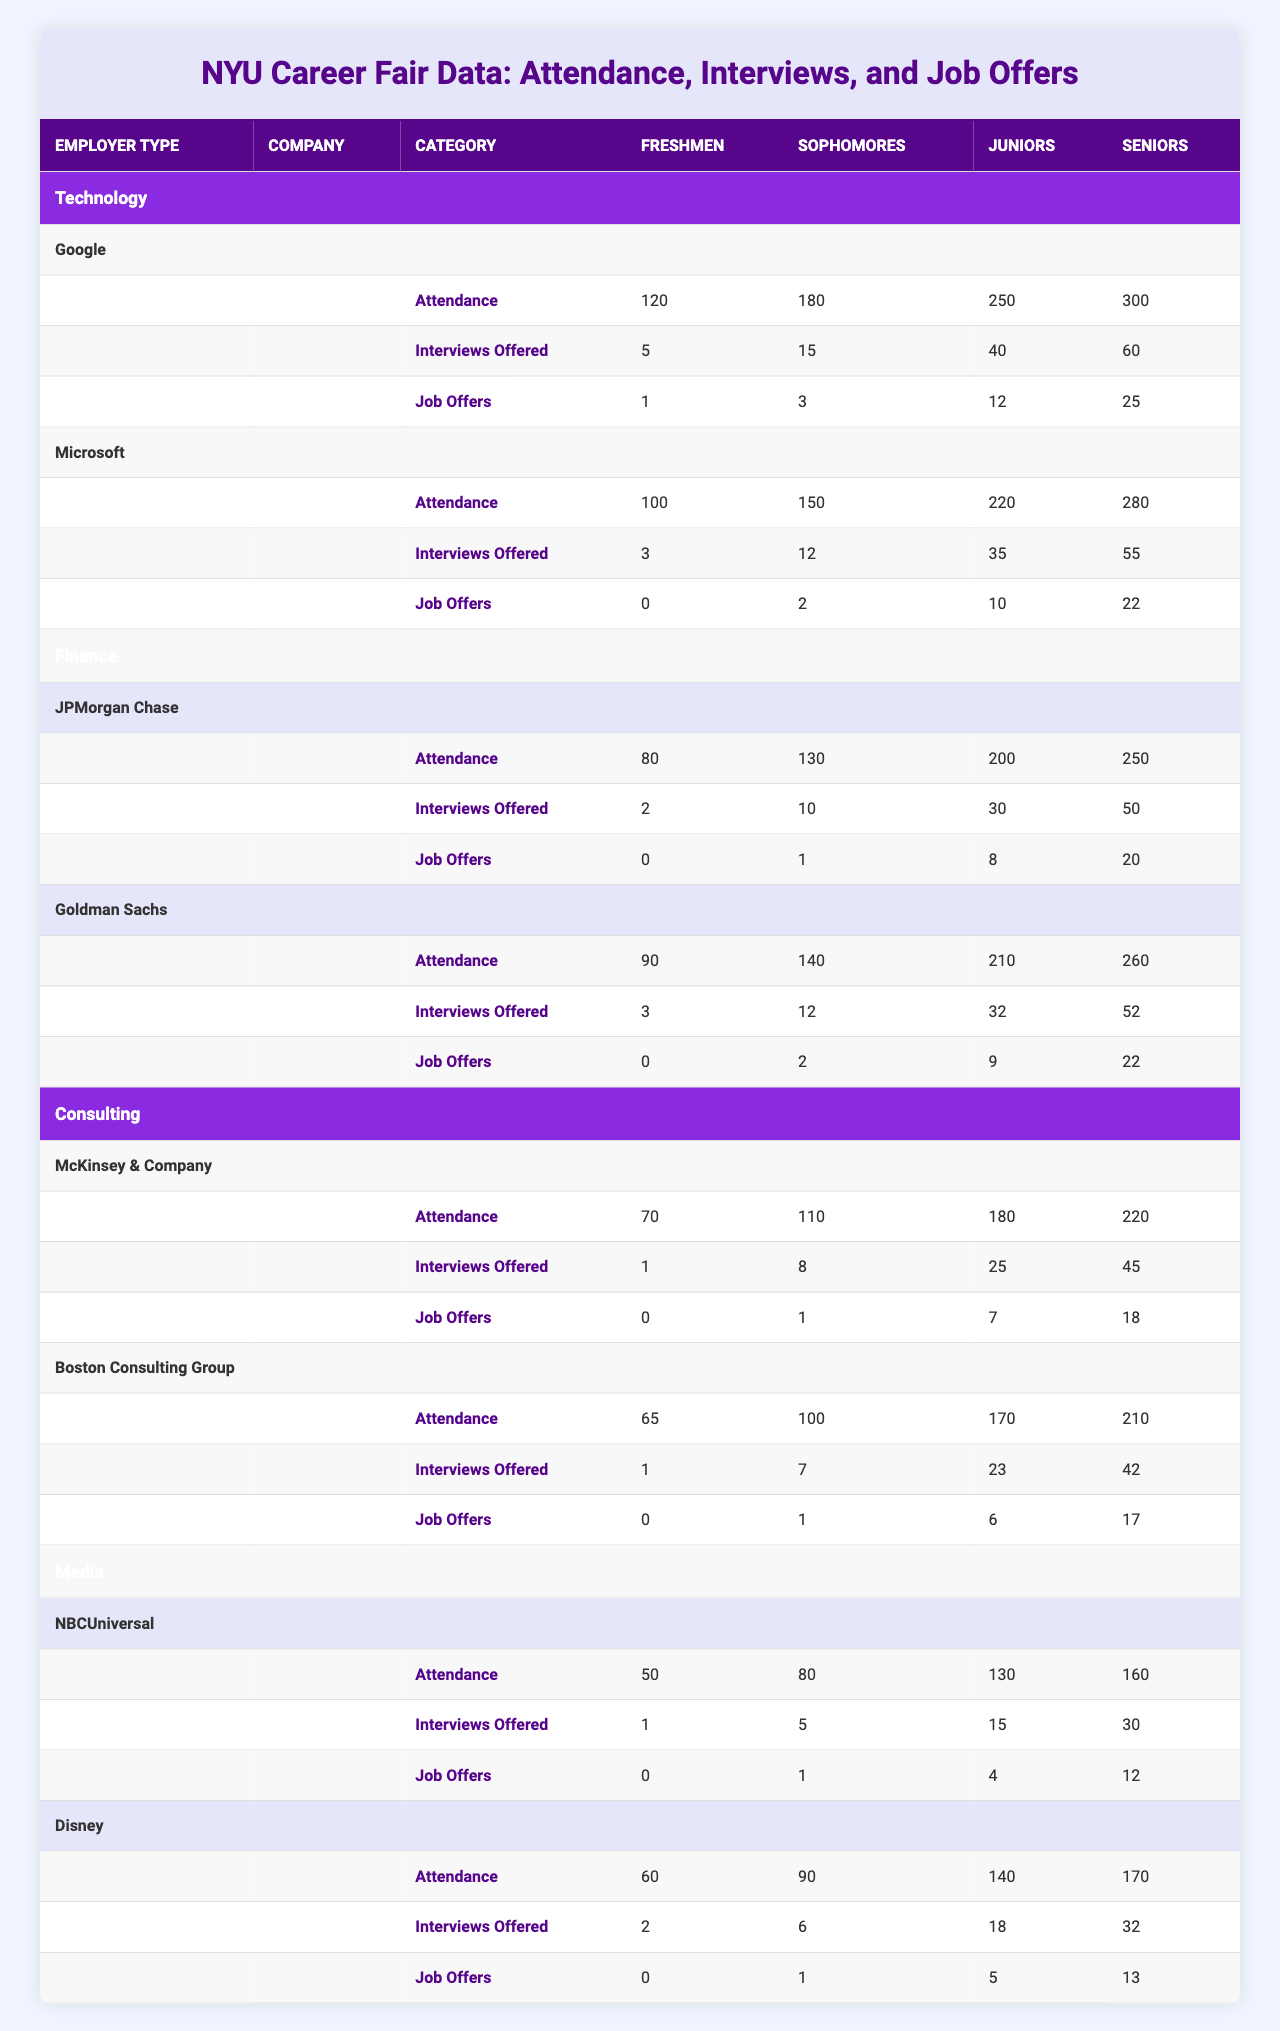What is the total attendance for Google among all student years? Google's attendance for Freshmen is 120, Sophomores is 180, Juniors is 250, and Seniors is 300. Adding these values together: 120 + 180 + 250 + 300 = 850.
Answer: 850 Which company had the highest number of job offers for Seniors? Looking at the data, Google offered 25 job offers to Seniors, while other companies like JPMorgan Chase offered 20 and Goldman Sachs also offered 22. Therefore, Google has the highest number of job offers for Seniors.
Answer: Google What is the average number of job offers for Sophomores across all companies? For Sophomores: Google offered 3, Microsoft 2, JPMorgan Chase 1, Goldman Sachs 2, McKinsey & Company 1, Boston Consulting Group 1, NBCUniversal 1, and Disney 1. The sum is 3 + 2 + 1 + 2 + 1 + 1 + 1 + 1 = 12. Since there are 8 companies, the average is 12 / 8 = 1.5.
Answer: 1.5 Did more Sophomores attend the Technology employers than the Finance employers combined? For Technology, Sophomore attendance was 180. For Finance, JPMorgan Chase had 130 and Goldman Sachs had 140, combined attendance is 130 + 140 = 270. Since 180 is less than 270, more Sophomores attended Finance employers.
Answer: No What is the total number of interviews offered to Juniors by Media employers? Media employers NBCUniversal offered 15 interviews and Disney offered 18 for Juniors. Adding these gives 15 + 18 = 33.
Answer: 33 Which employer type had the highest attendance from Freshmen? In the table, Technology has Google with 120 and Microsoft with 100 (total 220). Finance has JPMorgan Chase with 80 and Goldman Sachs with 90 (total 170). Consulting has McKinsey & Company with 70 and BCG with 65 (total 135). Media has NBCUniversal with 50 and Disney with 60 (total 110). Thus, Technology had the highest attendance from Freshmen.
Answer: Technology What is the difference in job offers between the highest and lowest for Juniors? The highest for Juniors is Google with 12 job offers, and the lowest is NBCUniversal and Disney, both offering 4. The difference is 12 - 4 = 8.
Answer: 8 Which company offered the most interviews to Seniors? Google offered 60 interviews to Seniors, Microsoft offered 55, JPMorgan Chase offered 50, Goldman Sachs offered 52, McKinsey & Company offered 45, BCG offered 42, NBCUniversal offered 30, and Disney offered 32. The highest is 60 from Google.
Answer: Google How many total interviews were offered to Freshmen across all employer types? For Freshmen: Google offered 5, Microsoft 3, JPMorgan Chase 2, Goldman Sachs 3, McKinsey & Company 1, BCG 1, NBCUniversal 1, and Disney 2. Adding these gives 5 + 3 + 2 + 3 + 1 + 1 + 1 + 2 = 18.
Answer: 18 What percentage of Sophomores got job offers from Goldman Sachs? Goldman Sachs offered 2 job offers to Sophomores, and 140 Sophomores attended. The percentage is (2/140) * 100 = 1.43%.
Answer: 1.43% 